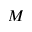Convert formula to latex. <formula><loc_0><loc_0><loc_500><loc_500>M</formula> 